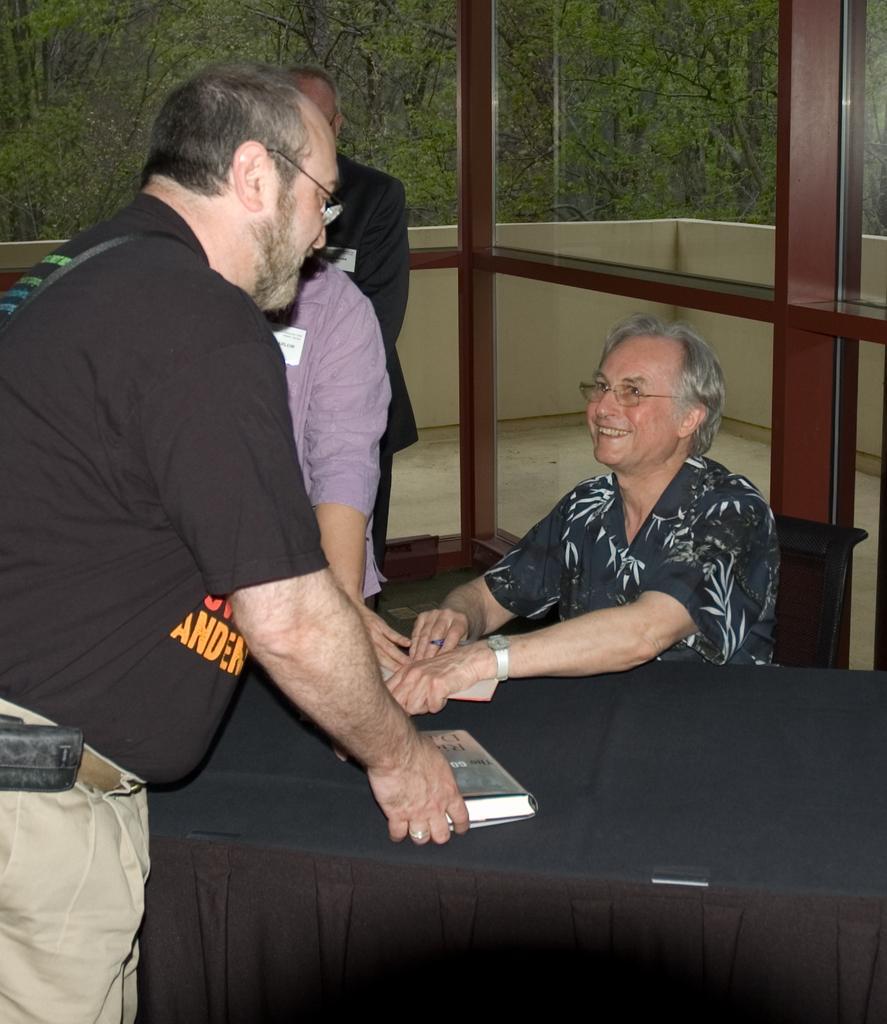Can you describe this image briefly? This is the picture of two people one sitting on table and one on chair and around we can see some trees. 